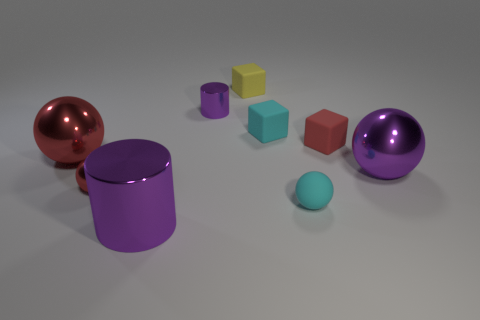What could be the purpose of this assortment of objects? This arrangement of objects may be designed to showcase a variety of shapes and colors, possibly for aesthetic exploration, or to illustrate concepts in geometry, light reflection, and material properties within a controlled environment. Could these objects serve any functional use in real life? While the objects in the image resemble simple geometric constructs you might find in a typical 3D modeling software library, in real life, they could metaphorically represent furniture or containers. However, without additional context, it's unclear if they are meant to be functional or are purely illustrative in nature. 